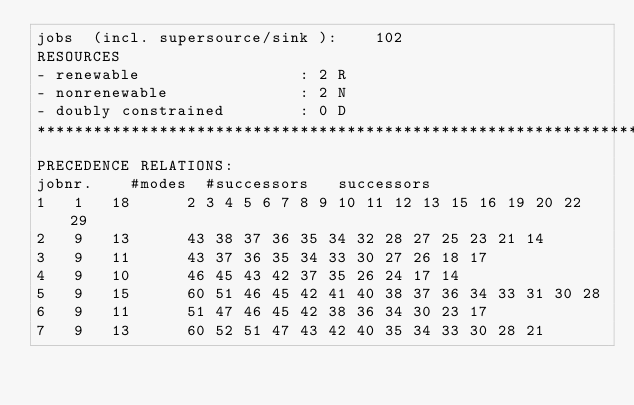Convert code to text. <code><loc_0><loc_0><loc_500><loc_500><_ObjectiveC_>jobs  (incl. supersource/sink ):	102
RESOURCES
- renewable                 : 2 R
- nonrenewable              : 2 N
- doubly constrained        : 0 D
************************************************************************
PRECEDENCE RELATIONS:
jobnr.    #modes  #successors   successors
1	1	18		2 3 4 5 6 7 8 9 10 11 12 13 15 16 19 20 22 29 
2	9	13		43 38 37 36 35 34 32 28 27 25 23 21 14 
3	9	11		43 37 36 35 34 33 30 27 26 18 17 
4	9	10		46 45 43 42 37 35 26 24 17 14 
5	9	15		60 51 46 45 42 41 40 38 37 36 34 33 31 30 28 
6	9	11		51 47 46 45 42 38 36 34 30 23 17 
7	9	13		60 52 51 47 43 42 40 35 34 33 30 28 21 </code> 